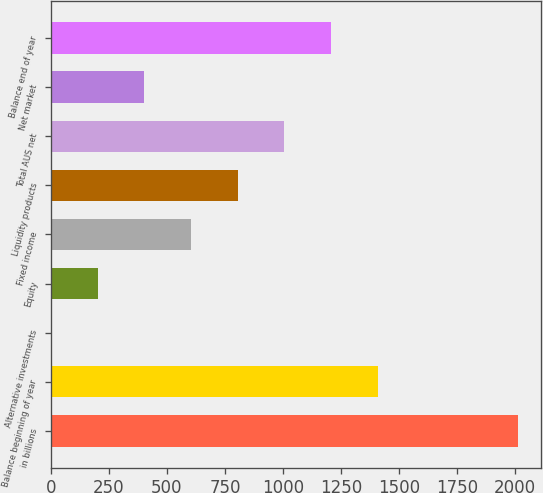<chart> <loc_0><loc_0><loc_500><loc_500><bar_chart><fcel>in billions<fcel>Balance beginning of year<fcel>Alternative investments<fcel>Equity<fcel>Fixed income<fcel>Liquidity products<fcel>Total AUS net<fcel>Net market<fcel>Balance end of year<nl><fcel>2011<fcel>1408<fcel>1<fcel>202<fcel>604<fcel>805<fcel>1006<fcel>403<fcel>1207<nl></chart> 